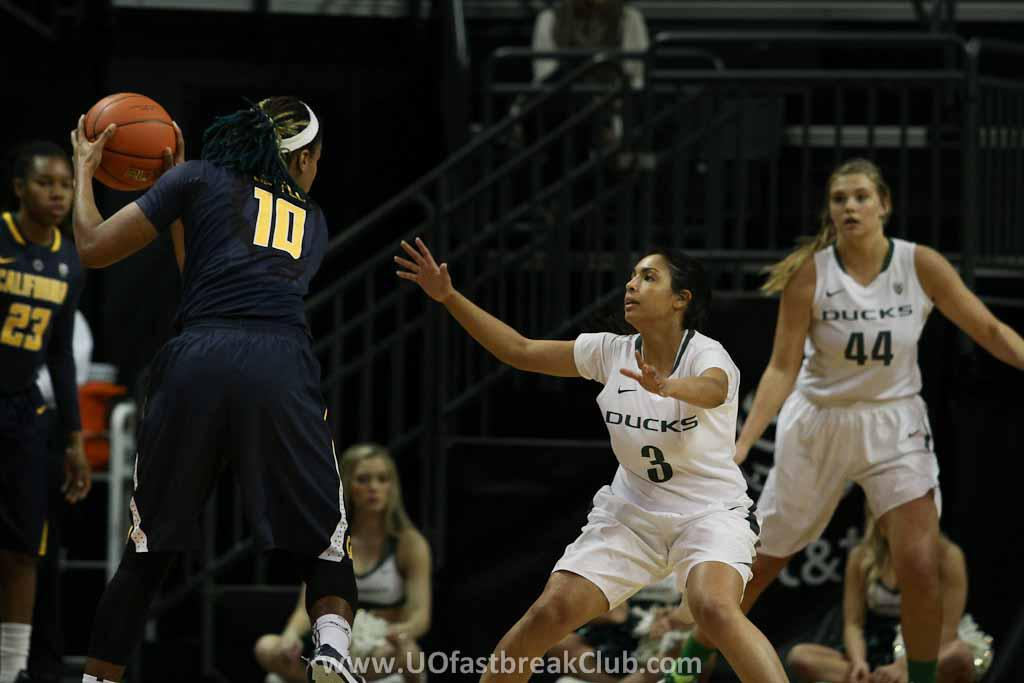What activity are the people in the image engaged in? The people in the image are playing basketball. Where is the basketball game taking place in the image? The basketball game is taking place in the center of the image. What can be found at the bottom of the image? There is some text at the bottom of the image. What architectural feature can be seen in the background of the image? There are staircase railings in the background of the image. What type of bag is being kicked around by the players during the basketball game? There is no bag present in the image, and the players are not kicking anything other than the basketball. 